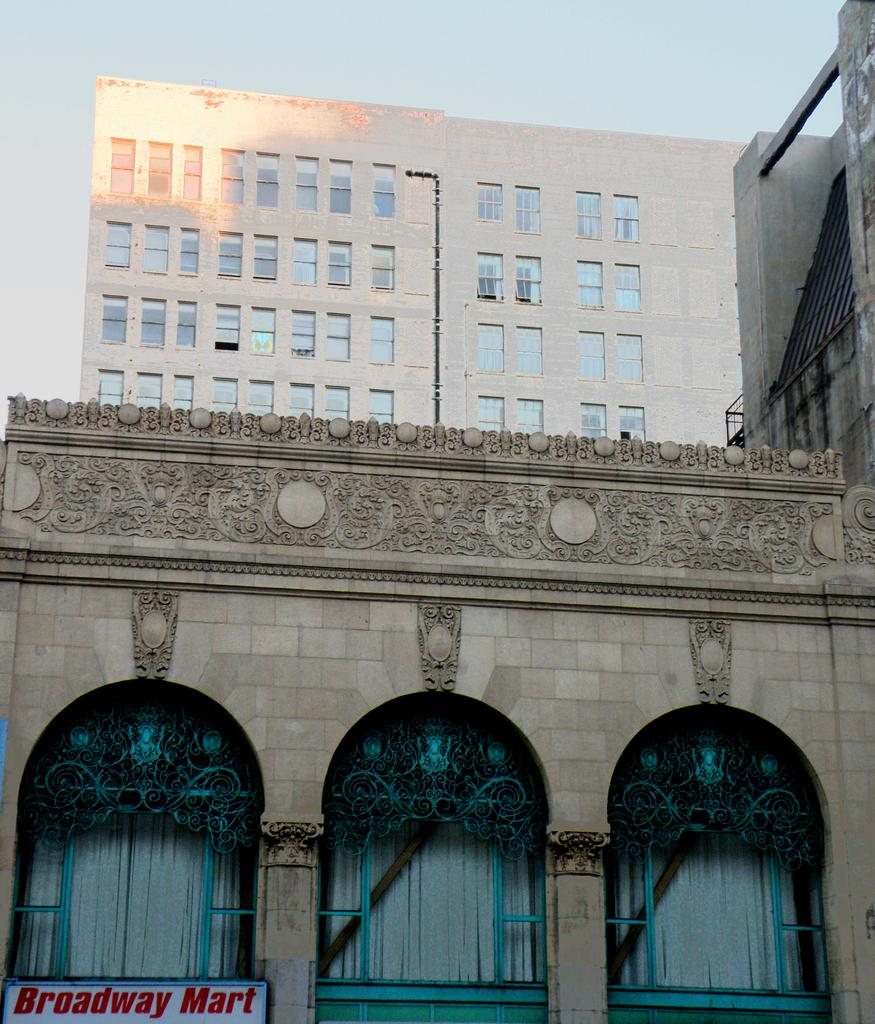What type of structures can be seen in the image? There are buildings in the image. Can you describe one of the buildings in more detail? Yes, there is a building with a pipe and windows. What about another building in the image? There is a building with windows and curtains. Is there any text visible in the image? Yes, there is a board with text in the image. What can be seen in the background of the image? The sky is visible in the background of the image. Where is the crow sitting on the dress in the image? There is no crow or dress present in the image. Can you tell me the color of the lake in the image? There is no lake present in the image. 